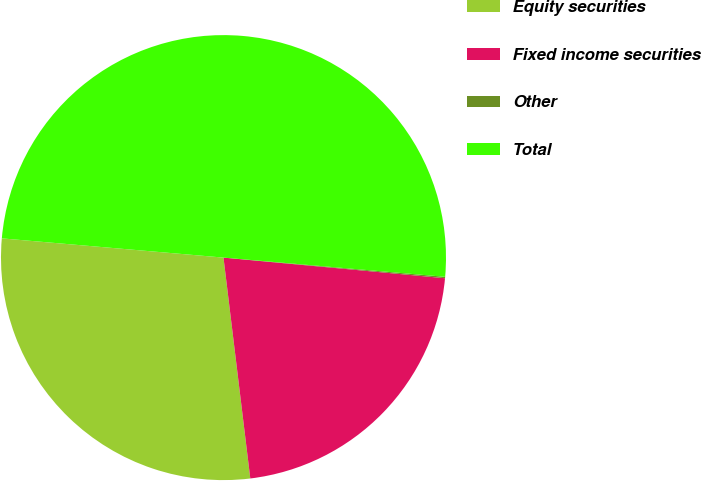Convert chart to OTSL. <chart><loc_0><loc_0><loc_500><loc_500><pie_chart><fcel>Equity securities<fcel>Fixed income securities<fcel>Other<fcel>Total<nl><fcel>28.3%<fcel>21.6%<fcel>0.1%<fcel>50.0%<nl></chart> 